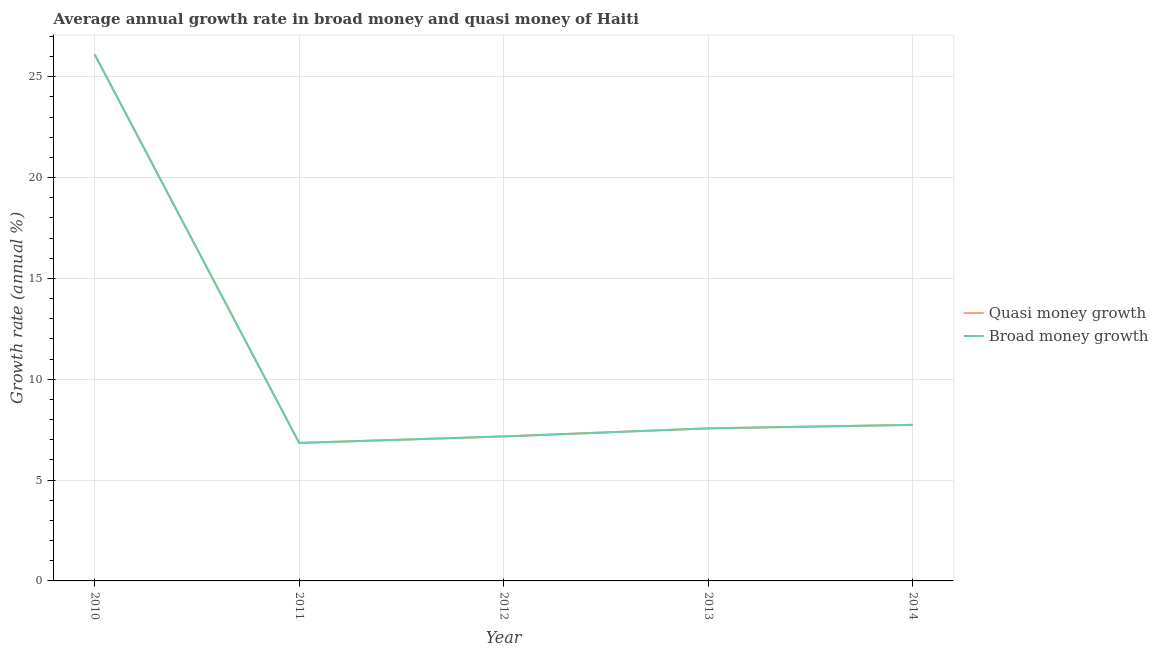How many different coloured lines are there?
Provide a succinct answer. 2. What is the annual growth rate in broad money in 2012?
Keep it short and to the point. 7.17. Across all years, what is the maximum annual growth rate in quasi money?
Provide a succinct answer. 26.12. Across all years, what is the minimum annual growth rate in quasi money?
Your answer should be compact. 6.84. What is the total annual growth rate in broad money in the graph?
Offer a terse response. 55.43. What is the difference between the annual growth rate in broad money in 2011 and that in 2013?
Provide a succinct answer. -0.72. What is the difference between the annual growth rate in quasi money in 2013 and the annual growth rate in broad money in 2011?
Offer a very short reply. 0.72. What is the average annual growth rate in broad money per year?
Your answer should be very brief. 11.09. In how many years, is the annual growth rate in broad money greater than 21 %?
Make the answer very short. 1. What is the ratio of the annual growth rate in quasi money in 2012 to that in 2014?
Offer a terse response. 0.93. Is the difference between the annual growth rate in broad money in 2011 and 2013 greater than the difference between the annual growth rate in quasi money in 2011 and 2013?
Your answer should be very brief. No. What is the difference between the highest and the second highest annual growth rate in broad money?
Your response must be concise. 18.38. What is the difference between the highest and the lowest annual growth rate in broad money?
Ensure brevity in your answer.  19.27. In how many years, is the annual growth rate in broad money greater than the average annual growth rate in broad money taken over all years?
Your response must be concise. 1. Is the sum of the annual growth rate in broad money in 2011 and 2012 greater than the maximum annual growth rate in quasi money across all years?
Ensure brevity in your answer.  No. Does the annual growth rate in quasi money monotonically increase over the years?
Your response must be concise. No. Is the annual growth rate in quasi money strictly greater than the annual growth rate in broad money over the years?
Offer a very short reply. No. Is the annual growth rate in broad money strictly less than the annual growth rate in quasi money over the years?
Ensure brevity in your answer.  No. What is the difference between two consecutive major ticks on the Y-axis?
Offer a very short reply. 5. How are the legend labels stacked?
Ensure brevity in your answer.  Vertical. What is the title of the graph?
Provide a short and direct response. Average annual growth rate in broad money and quasi money of Haiti. Does "Investments" appear as one of the legend labels in the graph?
Your answer should be compact. No. What is the label or title of the Y-axis?
Keep it short and to the point. Growth rate (annual %). What is the Growth rate (annual %) in Quasi money growth in 2010?
Offer a very short reply. 26.12. What is the Growth rate (annual %) of Broad money growth in 2010?
Give a very brief answer. 26.12. What is the Growth rate (annual %) of Quasi money growth in 2011?
Ensure brevity in your answer.  6.84. What is the Growth rate (annual %) of Broad money growth in 2011?
Provide a short and direct response. 6.84. What is the Growth rate (annual %) of Quasi money growth in 2012?
Offer a terse response. 7.17. What is the Growth rate (annual %) in Broad money growth in 2012?
Your answer should be compact. 7.17. What is the Growth rate (annual %) in Quasi money growth in 2013?
Keep it short and to the point. 7.57. What is the Growth rate (annual %) of Broad money growth in 2013?
Give a very brief answer. 7.57. What is the Growth rate (annual %) in Quasi money growth in 2014?
Ensure brevity in your answer.  7.74. What is the Growth rate (annual %) in Broad money growth in 2014?
Offer a terse response. 7.74. Across all years, what is the maximum Growth rate (annual %) in Quasi money growth?
Offer a terse response. 26.12. Across all years, what is the maximum Growth rate (annual %) of Broad money growth?
Offer a terse response. 26.12. Across all years, what is the minimum Growth rate (annual %) in Quasi money growth?
Offer a very short reply. 6.84. Across all years, what is the minimum Growth rate (annual %) in Broad money growth?
Keep it short and to the point. 6.84. What is the total Growth rate (annual %) in Quasi money growth in the graph?
Keep it short and to the point. 55.43. What is the total Growth rate (annual %) in Broad money growth in the graph?
Keep it short and to the point. 55.43. What is the difference between the Growth rate (annual %) in Quasi money growth in 2010 and that in 2011?
Give a very brief answer. 19.27. What is the difference between the Growth rate (annual %) in Broad money growth in 2010 and that in 2011?
Keep it short and to the point. 19.27. What is the difference between the Growth rate (annual %) of Quasi money growth in 2010 and that in 2012?
Give a very brief answer. 18.95. What is the difference between the Growth rate (annual %) of Broad money growth in 2010 and that in 2012?
Provide a short and direct response. 18.95. What is the difference between the Growth rate (annual %) in Quasi money growth in 2010 and that in 2013?
Offer a terse response. 18.55. What is the difference between the Growth rate (annual %) in Broad money growth in 2010 and that in 2013?
Provide a succinct answer. 18.55. What is the difference between the Growth rate (annual %) of Quasi money growth in 2010 and that in 2014?
Keep it short and to the point. 18.38. What is the difference between the Growth rate (annual %) in Broad money growth in 2010 and that in 2014?
Ensure brevity in your answer.  18.38. What is the difference between the Growth rate (annual %) of Quasi money growth in 2011 and that in 2012?
Ensure brevity in your answer.  -0.32. What is the difference between the Growth rate (annual %) in Broad money growth in 2011 and that in 2012?
Provide a succinct answer. -0.32. What is the difference between the Growth rate (annual %) of Quasi money growth in 2011 and that in 2013?
Your answer should be compact. -0.72. What is the difference between the Growth rate (annual %) of Broad money growth in 2011 and that in 2013?
Your answer should be very brief. -0.72. What is the difference between the Growth rate (annual %) in Quasi money growth in 2011 and that in 2014?
Give a very brief answer. -0.9. What is the difference between the Growth rate (annual %) of Broad money growth in 2011 and that in 2014?
Your answer should be compact. -0.9. What is the difference between the Growth rate (annual %) of Quasi money growth in 2012 and that in 2013?
Keep it short and to the point. -0.4. What is the difference between the Growth rate (annual %) of Broad money growth in 2012 and that in 2013?
Provide a succinct answer. -0.4. What is the difference between the Growth rate (annual %) of Quasi money growth in 2012 and that in 2014?
Offer a very short reply. -0.57. What is the difference between the Growth rate (annual %) in Broad money growth in 2012 and that in 2014?
Offer a very short reply. -0.57. What is the difference between the Growth rate (annual %) in Quasi money growth in 2013 and that in 2014?
Offer a very short reply. -0.17. What is the difference between the Growth rate (annual %) of Broad money growth in 2013 and that in 2014?
Your response must be concise. -0.17. What is the difference between the Growth rate (annual %) of Quasi money growth in 2010 and the Growth rate (annual %) of Broad money growth in 2011?
Keep it short and to the point. 19.27. What is the difference between the Growth rate (annual %) of Quasi money growth in 2010 and the Growth rate (annual %) of Broad money growth in 2012?
Your answer should be very brief. 18.95. What is the difference between the Growth rate (annual %) of Quasi money growth in 2010 and the Growth rate (annual %) of Broad money growth in 2013?
Offer a terse response. 18.55. What is the difference between the Growth rate (annual %) of Quasi money growth in 2010 and the Growth rate (annual %) of Broad money growth in 2014?
Your answer should be compact. 18.38. What is the difference between the Growth rate (annual %) in Quasi money growth in 2011 and the Growth rate (annual %) in Broad money growth in 2012?
Make the answer very short. -0.32. What is the difference between the Growth rate (annual %) in Quasi money growth in 2011 and the Growth rate (annual %) in Broad money growth in 2013?
Your answer should be very brief. -0.72. What is the difference between the Growth rate (annual %) of Quasi money growth in 2011 and the Growth rate (annual %) of Broad money growth in 2014?
Your answer should be very brief. -0.9. What is the difference between the Growth rate (annual %) in Quasi money growth in 2012 and the Growth rate (annual %) in Broad money growth in 2013?
Make the answer very short. -0.4. What is the difference between the Growth rate (annual %) of Quasi money growth in 2012 and the Growth rate (annual %) of Broad money growth in 2014?
Provide a succinct answer. -0.57. What is the difference between the Growth rate (annual %) in Quasi money growth in 2013 and the Growth rate (annual %) in Broad money growth in 2014?
Ensure brevity in your answer.  -0.17. What is the average Growth rate (annual %) in Quasi money growth per year?
Provide a short and direct response. 11.09. What is the average Growth rate (annual %) in Broad money growth per year?
Make the answer very short. 11.09. In the year 2012, what is the difference between the Growth rate (annual %) in Quasi money growth and Growth rate (annual %) in Broad money growth?
Offer a very short reply. 0. In the year 2013, what is the difference between the Growth rate (annual %) in Quasi money growth and Growth rate (annual %) in Broad money growth?
Provide a succinct answer. 0. In the year 2014, what is the difference between the Growth rate (annual %) in Quasi money growth and Growth rate (annual %) in Broad money growth?
Offer a terse response. 0. What is the ratio of the Growth rate (annual %) in Quasi money growth in 2010 to that in 2011?
Keep it short and to the point. 3.82. What is the ratio of the Growth rate (annual %) of Broad money growth in 2010 to that in 2011?
Your answer should be compact. 3.82. What is the ratio of the Growth rate (annual %) of Quasi money growth in 2010 to that in 2012?
Offer a very short reply. 3.64. What is the ratio of the Growth rate (annual %) in Broad money growth in 2010 to that in 2012?
Your response must be concise. 3.64. What is the ratio of the Growth rate (annual %) of Quasi money growth in 2010 to that in 2013?
Ensure brevity in your answer.  3.45. What is the ratio of the Growth rate (annual %) in Broad money growth in 2010 to that in 2013?
Keep it short and to the point. 3.45. What is the ratio of the Growth rate (annual %) of Quasi money growth in 2010 to that in 2014?
Give a very brief answer. 3.37. What is the ratio of the Growth rate (annual %) in Broad money growth in 2010 to that in 2014?
Keep it short and to the point. 3.37. What is the ratio of the Growth rate (annual %) in Quasi money growth in 2011 to that in 2012?
Your answer should be compact. 0.95. What is the ratio of the Growth rate (annual %) in Broad money growth in 2011 to that in 2012?
Your response must be concise. 0.95. What is the ratio of the Growth rate (annual %) of Quasi money growth in 2011 to that in 2013?
Ensure brevity in your answer.  0.9. What is the ratio of the Growth rate (annual %) in Broad money growth in 2011 to that in 2013?
Give a very brief answer. 0.9. What is the ratio of the Growth rate (annual %) of Quasi money growth in 2011 to that in 2014?
Your response must be concise. 0.88. What is the ratio of the Growth rate (annual %) of Broad money growth in 2011 to that in 2014?
Give a very brief answer. 0.88. What is the ratio of the Growth rate (annual %) in Quasi money growth in 2012 to that in 2013?
Provide a short and direct response. 0.95. What is the ratio of the Growth rate (annual %) in Broad money growth in 2012 to that in 2013?
Your answer should be compact. 0.95. What is the ratio of the Growth rate (annual %) of Quasi money growth in 2012 to that in 2014?
Keep it short and to the point. 0.93. What is the ratio of the Growth rate (annual %) in Broad money growth in 2012 to that in 2014?
Offer a terse response. 0.93. What is the ratio of the Growth rate (annual %) in Quasi money growth in 2013 to that in 2014?
Your answer should be very brief. 0.98. What is the ratio of the Growth rate (annual %) of Broad money growth in 2013 to that in 2014?
Ensure brevity in your answer.  0.98. What is the difference between the highest and the second highest Growth rate (annual %) in Quasi money growth?
Offer a terse response. 18.38. What is the difference between the highest and the second highest Growth rate (annual %) in Broad money growth?
Provide a succinct answer. 18.38. What is the difference between the highest and the lowest Growth rate (annual %) in Quasi money growth?
Keep it short and to the point. 19.27. What is the difference between the highest and the lowest Growth rate (annual %) in Broad money growth?
Offer a terse response. 19.27. 